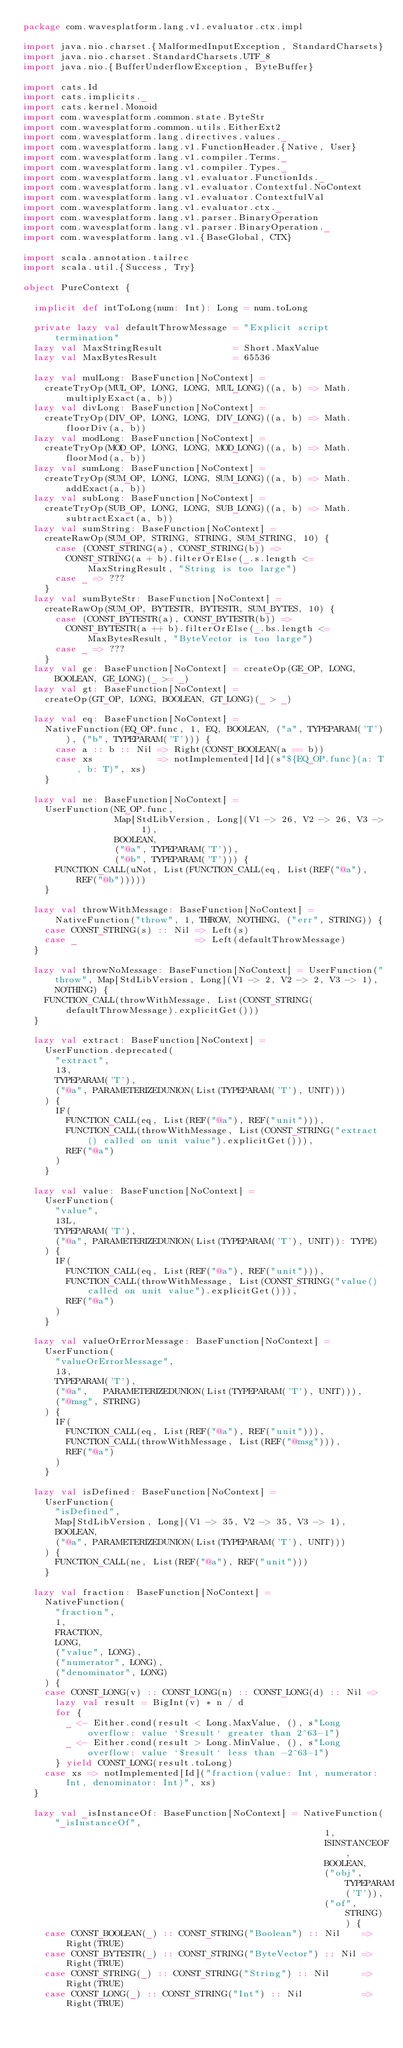Convert code to text. <code><loc_0><loc_0><loc_500><loc_500><_Scala_>package com.wavesplatform.lang.v1.evaluator.ctx.impl

import java.nio.charset.{MalformedInputException, StandardCharsets}
import java.nio.charset.StandardCharsets.UTF_8
import java.nio.{BufferUnderflowException, ByteBuffer}

import cats.Id
import cats.implicits._
import cats.kernel.Monoid
import com.wavesplatform.common.state.ByteStr
import com.wavesplatform.common.utils.EitherExt2
import com.wavesplatform.lang.directives.values._
import com.wavesplatform.lang.v1.FunctionHeader.{Native, User}
import com.wavesplatform.lang.v1.compiler.Terms._
import com.wavesplatform.lang.v1.compiler.Types._
import com.wavesplatform.lang.v1.evaluator.FunctionIds._
import com.wavesplatform.lang.v1.evaluator.Contextful.NoContext
import com.wavesplatform.lang.v1.evaluator.ContextfulVal
import com.wavesplatform.lang.v1.evaluator.ctx._
import com.wavesplatform.lang.v1.parser.BinaryOperation
import com.wavesplatform.lang.v1.parser.BinaryOperation._
import com.wavesplatform.lang.v1.{BaseGlobal, CTX}

import scala.annotation.tailrec
import scala.util.{Success, Try}

object PureContext {

  implicit def intToLong(num: Int): Long = num.toLong

  private lazy val defaultThrowMessage = "Explicit script termination"
  lazy val MaxStringResult             = Short.MaxValue
  lazy val MaxBytesResult              = 65536

  lazy val mulLong: BaseFunction[NoContext] =
    createTryOp(MUL_OP, LONG, LONG, MUL_LONG)((a, b) => Math.multiplyExact(a, b))
  lazy val divLong: BaseFunction[NoContext] =
    createTryOp(DIV_OP, LONG, LONG, DIV_LONG)((a, b) => Math.floorDiv(a, b))
  lazy val modLong: BaseFunction[NoContext] =
    createTryOp(MOD_OP, LONG, LONG, MOD_LONG)((a, b) => Math.floorMod(a, b))
  lazy val sumLong: BaseFunction[NoContext] =
    createTryOp(SUM_OP, LONG, LONG, SUM_LONG)((a, b) => Math.addExact(a, b))
  lazy val subLong: BaseFunction[NoContext] =
    createTryOp(SUB_OP, LONG, LONG, SUB_LONG)((a, b) => Math.subtractExact(a, b))
  lazy val sumString: BaseFunction[NoContext] =
    createRawOp(SUM_OP, STRING, STRING, SUM_STRING, 10) {
      case (CONST_STRING(a), CONST_STRING(b)) =>
        CONST_STRING(a + b).filterOrElse(_.s.length <= MaxStringResult, "String is too large")
      case _ => ???
    }
  lazy val sumByteStr: BaseFunction[NoContext] =
    createRawOp(SUM_OP, BYTESTR, BYTESTR, SUM_BYTES, 10) {
      case (CONST_BYTESTR(a), CONST_BYTESTR(b)) =>
        CONST_BYTESTR(a ++ b).filterOrElse(_.bs.length <= MaxBytesResult, "ByteVector is too large")
      case _ => ???
    }
  lazy val ge: BaseFunction[NoContext] = createOp(GE_OP, LONG, BOOLEAN, GE_LONG)(_ >= _)
  lazy val gt: BaseFunction[NoContext] =
    createOp(GT_OP, LONG, BOOLEAN, GT_LONG)(_ > _)

  lazy val eq: BaseFunction[NoContext] =
    NativeFunction(EQ_OP.func, 1, EQ, BOOLEAN, ("a", TYPEPARAM('T')), ("b", TYPEPARAM('T'))) {
      case a :: b :: Nil => Right(CONST_BOOLEAN(a == b))
      case xs            => notImplemented[Id](s"${EQ_OP.func}(a: T, b: T)", xs)
    }

  lazy val ne: BaseFunction[NoContext] =
    UserFunction(NE_OP.func,
                 Map[StdLibVersion, Long](V1 -> 26, V2 -> 26, V3 -> 1),
                 BOOLEAN,
                 ("@a", TYPEPARAM('T')),
                 ("@b", TYPEPARAM('T'))) {
      FUNCTION_CALL(uNot, List(FUNCTION_CALL(eq, List(REF("@a"), REF("@b")))))
    }

  lazy val throwWithMessage: BaseFunction[NoContext] = NativeFunction("throw", 1, THROW, NOTHING, ("err", STRING)) {
    case CONST_STRING(s) :: Nil => Left(s)
    case _                      => Left(defaultThrowMessage)
  }

  lazy val throwNoMessage: BaseFunction[NoContext] = UserFunction("throw", Map[StdLibVersion, Long](V1 -> 2, V2 -> 2, V3 -> 1), NOTHING) {
    FUNCTION_CALL(throwWithMessage, List(CONST_STRING(defaultThrowMessage).explicitGet()))
  }

  lazy val extract: BaseFunction[NoContext] =
    UserFunction.deprecated(
      "extract",
      13,
      TYPEPARAM('T'),
      ("@a", PARAMETERIZEDUNION(List(TYPEPARAM('T'), UNIT)))
    ) {
      IF(
        FUNCTION_CALL(eq, List(REF("@a"), REF("unit"))),
        FUNCTION_CALL(throwWithMessage, List(CONST_STRING("extract() called on unit value").explicitGet())),
        REF("@a")
      )
    }

  lazy val value: BaseFunction[NoContext] =
    UserFunction(
      "value",
      13L,
      TYPEPARAM('T'),
      ("@a", PARAMETERIZEDUNION(List(TYPEPARAM('T'), UNIT)): TYPE)
    ) {
      IF(
        FUNCTION_CALL(eq, List(REF("@a"), REF("unit"))),
        FUNCTION_CALL(throwWithMessage, List(CONST_STRING("value() called on unit value").explicitGet())),
        REF("@a")
      )
    }

  lazy val valueOrErrorMessage: BaseFunction[NoContext] =
    UserFunction(
      "valueOrErrorMessage",
      13,
      TYPEPARAM('T'),
      ("@a",   PARAMETERIZEDUNION(List(TYPEPARAM('T'), UNIT))),
      ("@msg", STRING)
    ) {
      IF(
        FUNCTION_CALL(eq, List(REF("@a"), REF("unit"))),
        FUNCTION_CALL(throwWithMessage, List(REF("@msg"))),
        REF("@a")
      )
    }

  lazy val isDefined: BaseFunction[NoContext] =
    UserFunction(
      "isDefined",
      Map[StdLibVersion, Long](V1 -> 35, V2 -> 35, V3 -> 1),
      BOOLEAN,
      ("@a", PARAMETERIZEDUNION(List(TYPEPARAM('T'), UNIT)))
    ) {
      FUNCTION_CALL(ne, List(REF("@a"), REF("unit")))
    }

  lazy val fraction: BaseFunction[NoContext] =
    NativeFunction(
      "fraction",
      1,
      FRACTION,
      LONG,
      ("value", LONG),
      ("numerator", LONG),
      ("denominator", LONG)
    ) {
    case CONST_LONG(v) :: CONST_LONG(n) :: CONST_LONG(d) :: Nil =>
      lazy val result = BigInt(v) * n / d
      for {
        _ <- Either.cond(result < Long.MaxValue, (), s"Long overflow: value `$result` greater than 2^63-1")
        _ <- Either.cond(result > Long.MinValue, (), s"Long overflow: value `$result` less than -2^63-1")
      } yield CONST_LONG(result.toLong)
    case xs => notImplemented[Id]("fraction(value: Int, numerator: Int, denominator: Int)", xs)
  }

  lazy val _isInstanceOf: BaseFunction[NoContext] = NativeFunction("_isInstanceOf",
                                                        1,
                                                        ISINSTANCEOF,
                                                        BOOLEAN,
                                                        ("obj", TYPEPARAM('T')),
                                                        ("of", STRING)) {
    case CONST_BOOLEAN(_) :: CONST_STRING("Boolean") :: Nil    => Right(TRUE)
    case CONST_BYTESTR(_) :: CONST_STRING("ByteVector") :: Nil => Right(TRUE)
    case CONST_STRING(_) :: CONST_STRING("String") :: Nil      => Right(TRUE)
    case CONST_LONG(_) :: CONST_STRING("Int") :: Nil           => Right(TRUE)</code> 